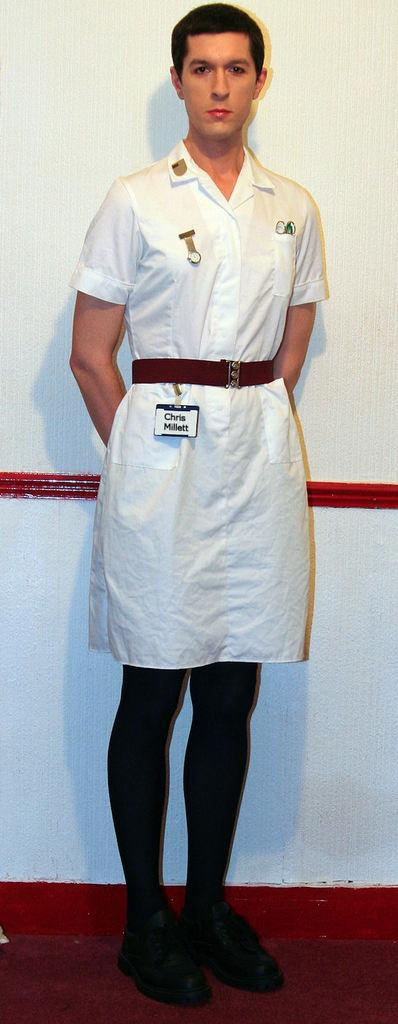<image>
Create a compact narrative representing the image presented. A man with a nametag labelled Chris Millett wears a white nurse's dress 